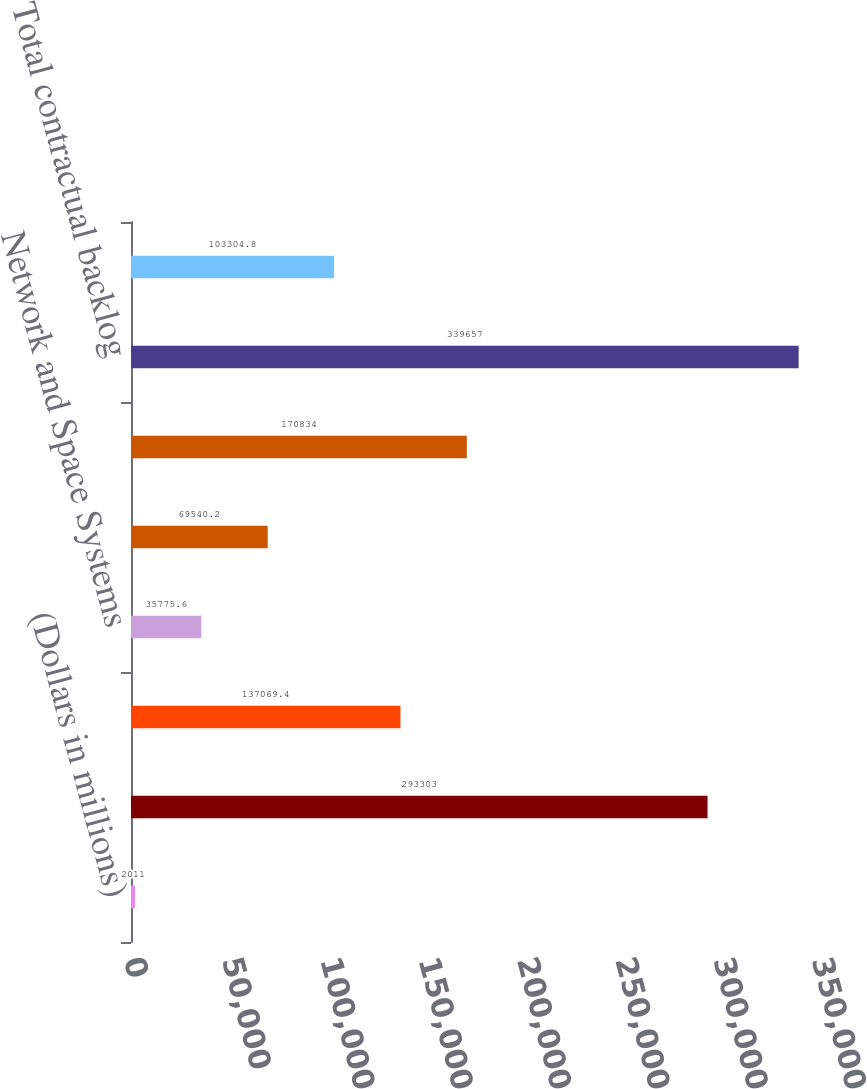<chart> <loc_0><loc_0><loc_500><loc_500><bar_chart><fcel>(Dollars in millions)<fcel>Commercial Airplanes<fcel>Boeing Military Aircraft<fcel>Network and Space Systems<fcel>Global Services and Support<fcel>Total Defense Space & Security<fcel>Total contractual backlog<fcel>Unobligated backlog<nl><fcel>2011<fcel>293303<fcel>137069<fcel>35775.6<fcel>69540.2<fcel>170834<fcel>339657<fcel>103305<nl></chart> 